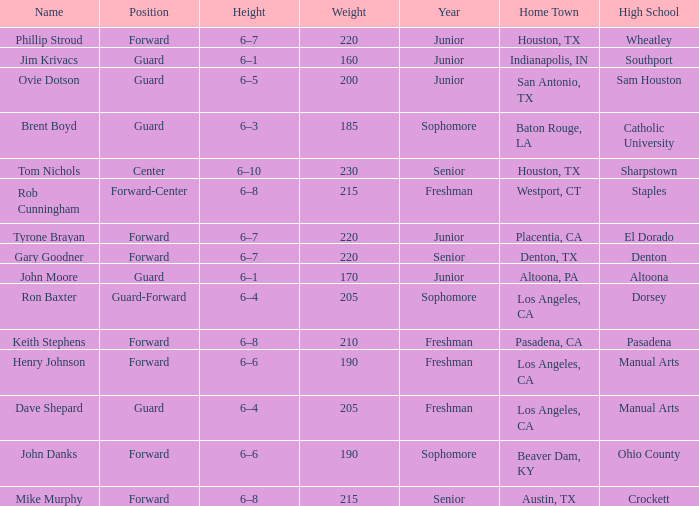Would you mind parsing the complete table? {'header': ['Name', 'Position', 'Height', 'Weight', 'Year', 'Home Town', 'High School'], 'rows': [['Phillip Stroud', 'Forward', '6–7', '220', 'Junior', 'Houston, TX', 'Wheatley'], ['Jim Krivacs', 'Guard', '6–1', '160', 'Junior', 'Indianapolis, IN', 'Southport'], ['Ovie Dotson', 'Guard', '6–5', '200', 'Junior', 'San Antonio, TX', 'Sam Houston'], ['Brent Boyd', 'Guard', '6–3', '185', 'Sophomore', 'Baton Rouge, LA', 'Catholic University'], ['Tom Nichols', 'Center', '6–10', '230', 'Senior', 'Houston, TX', 'Sharpstown'], ['Rob Cunningham', 'Forward-Center', '6–8', '215', 'Freshman', 'Westport, CT', 'Staples'], ['Tyrone Brayan', 'Forward', '6–7', '220', 'Junior', 'Placentia, CA', 'El Dorado'], ['Gary Goodner', 'Forward', '6–7', '220', 'Senior', 'Denton, TX', 'Denton'], ['John Moore', 'Guard', '6–1', '170', 'Junior', 'Altoona, PA', 'Altoona'], ['Ron Baxter', 'Guard-Forward', '6–4', '205', 'Sophomore', 'Los Angeles, CA', 'Dorsey'], ['Keith Stephens', 'Forward', '6–8', '210', 'Freshman', 'Pasadena, CA', 'Pasadena'], ['Henry Johnson', 'Forward', '6–6', '190', 'Freshman', 'Los Angeles, CA', 'Manual Arts'], ['Dave Shepard', 'Guard', '6–4', '205', 'Freshman', 'Los Angeles, CA', 'Manual Arts'], ['John Danks', 'Forward', '6–6', '190', 'Sophomore', 'Beaver Dam, KY', 'Ohio County'], ['Mike Murphy', 'Forward', '6–8', '215', 'Senior', 'Austin, TX', 'Crockett']]} What is the Position with a Year with freshman, and a Weight larger than 210? Forward-Center. 